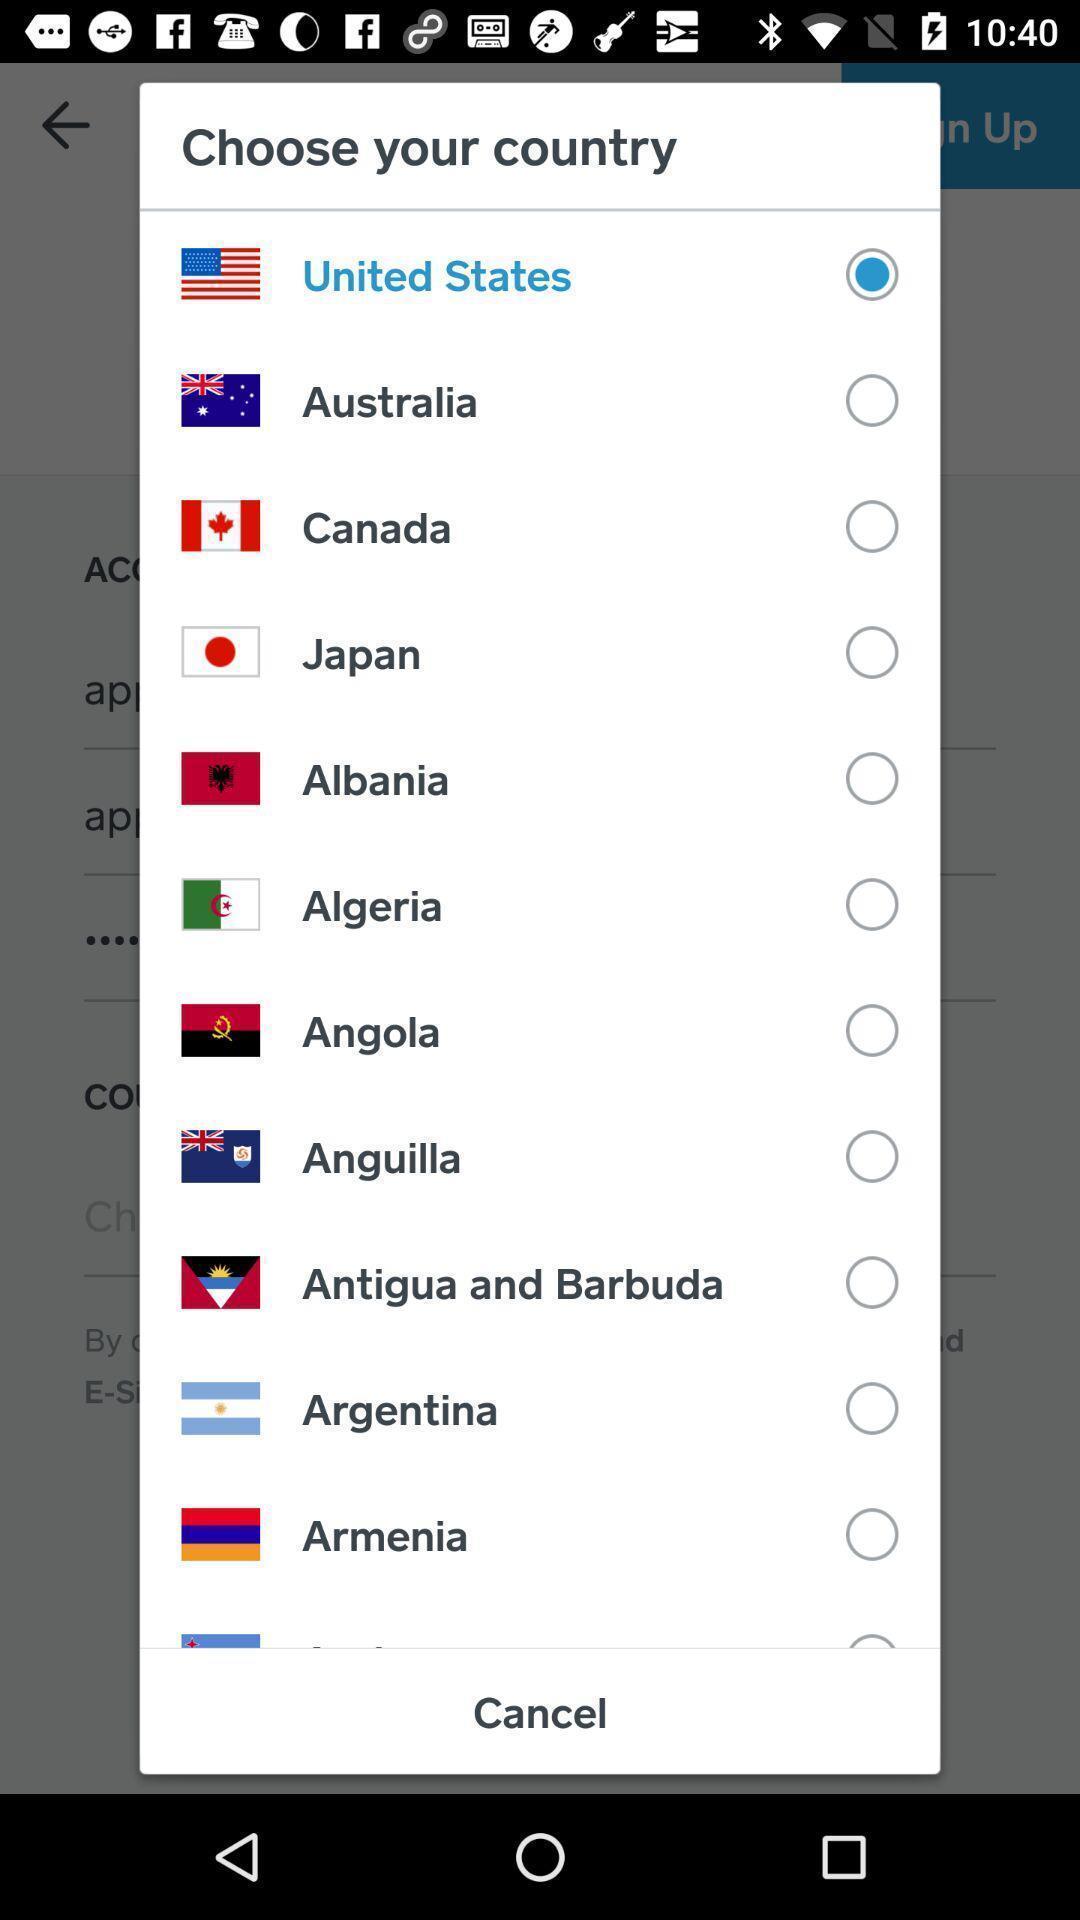Tell me about the visual elements in this screen capture. Pop-up showing list of various cities. 